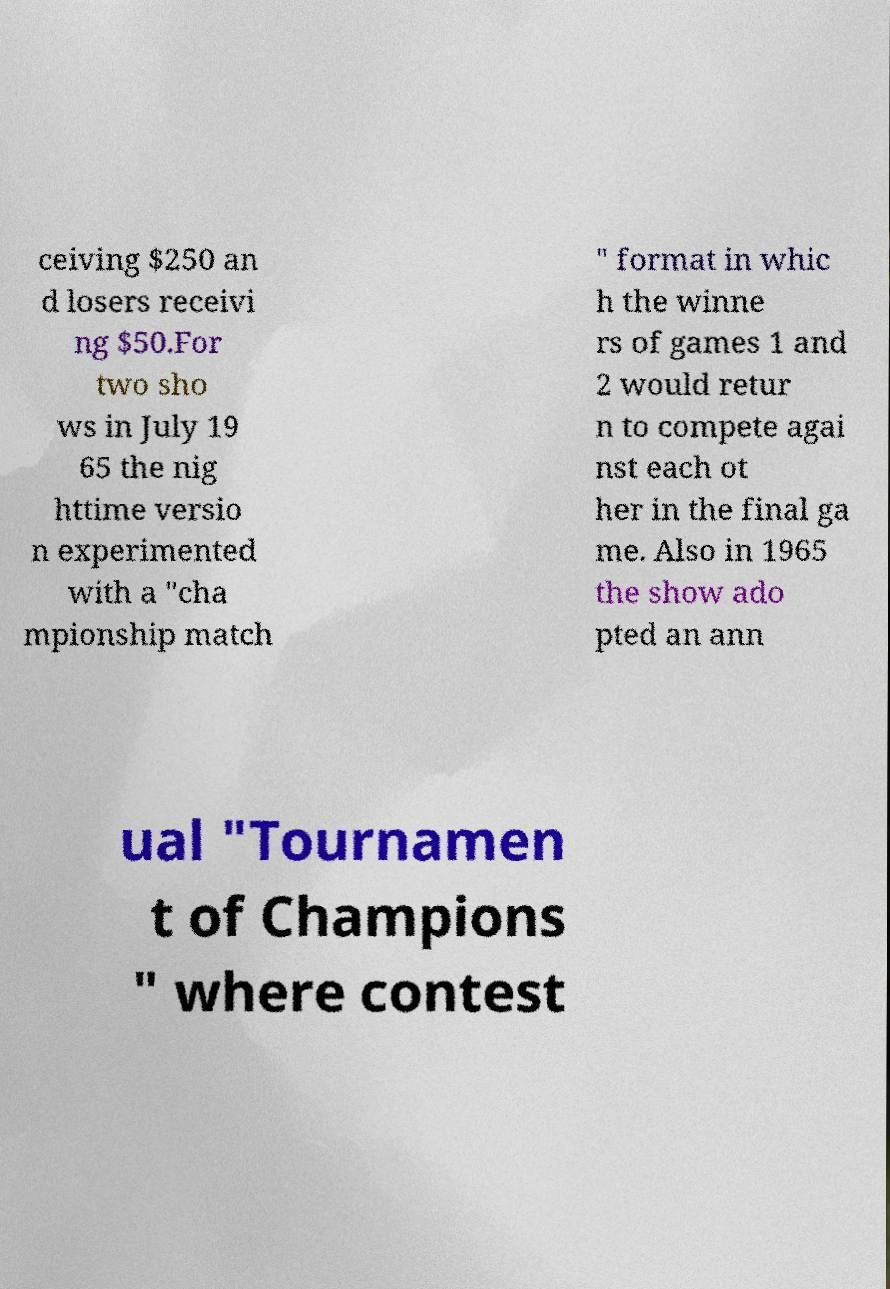Can you read and provide the text displayed in the image?This photo seems to have some interesting text. Can you extract and type it out for me? ceiving $250 an d losers receivi ng $50.For two sho ws in July 19 65 the nig httime versio n experimented with a "cha mpionship match " format in whic h the winne rs of games 1 and 2 would retur n to compete agai nst each ot her in the final ga me. Also in 1965 the show ado pted an ann ual "Tournamen t of Champions " where contest 